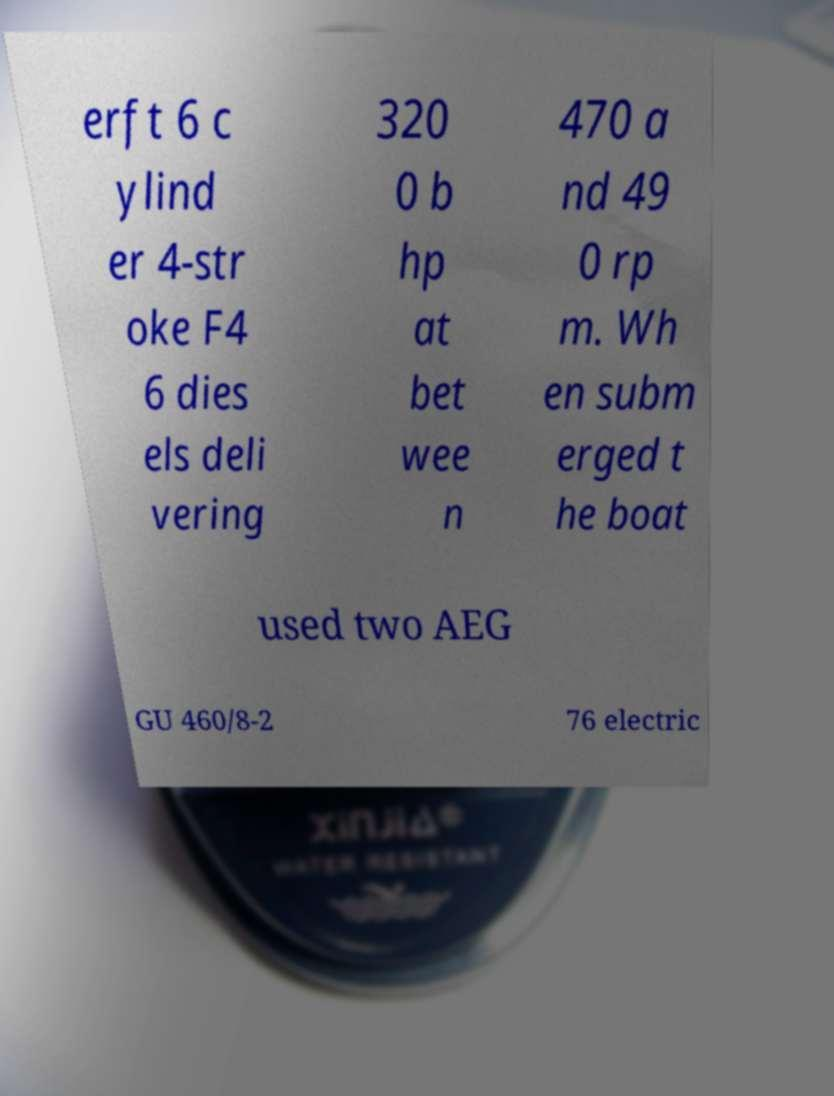Can you read and provide the text displayed in the image?This photo seems to have some interesting text. Can you extract and type it out for me? erft 6 c ylind er 4-str oke F4 6 dies els deli vering 320 0 b hp at bet wee n 470 a nd 49 0 rp m. Wh en subm erged t he boat used two AEG GU 460/8-2 76 electric 